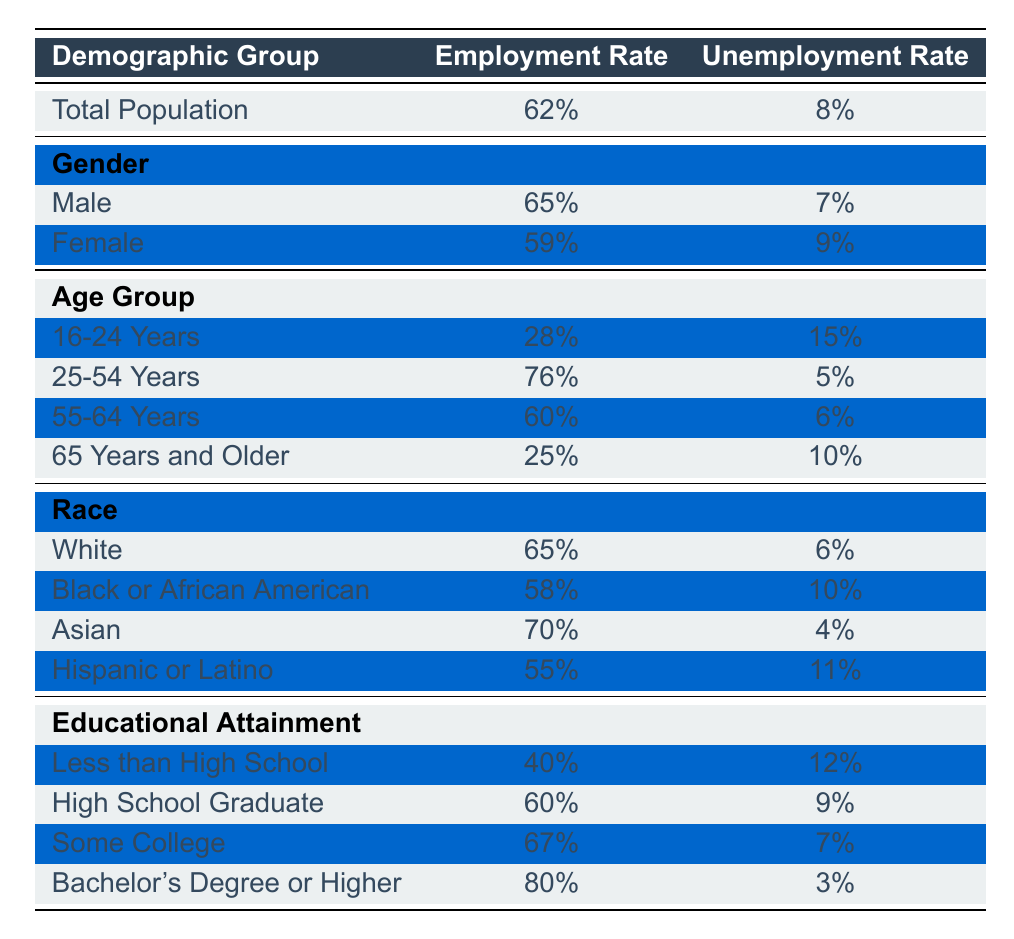What is the employment rate for the total population? The table lists the total employment rate for the population under "Total Population." That rate is explicitly stated as 62%.
Answer: 62% What is the unemployment rate for females? The unemployment rate for females is provided under the "Gender" section in the table, which states that the unemployment rate is 9%.
Answer: 9% Which age group has the highest employment rate? By reviewing the "Age Group" section, we see that the employment rates are: 16-24 Years (28%), 25-54 Years (76%), 55-64 Years (60%), and 65 Years and Older (25%). The highest is 76% for the 25-54 Years group.
Answer: 25-54 Years Is the unemployment rate for Black or African American individuals higher than that of White individuals? The unemployment rate for Black or African American individuals is 10% while for White individuals it is 6%. Since 10% is greater than 6%, the statement is true.
Answer: Yes What is the difference in employment rates between males and females? The employment rate for males is 65%, and for females, it is 59%. The difference can be calculated as 65% - 59% = 6%.
Answer: 6% What is the average employment rate for individuals with a Bachelor's Degree or Higher compared to those with less than a High School diploma? The employment rate for a Bachelor's Degree or Higher is 80%, and for Less than High School, it is 40%. To find the average, add both and divide by 2: (80% + 40%) / 2 = 60%.
Answer: 60% Does the employment rate for the Asian demographic group exceed 70%? The employment rate for the Asian demographic group is listed as 70%. Since it is not greater than 70%, the statement is false.
Answer: No Which demographic has the lowest unemployment rate? Looking through all sections, the lowest unemployment rate is found in the "Bachelor's Degree or Higher" category at 3%. This is lower than other groups specified in the table.
Answer: Bachelor's Degree or Higher What is the average employment rate for the age groups 55-64 Years and 65 Years and Older? The employment rates for these age groups are 60% for 55-64 Years and 25% for 65 Years and Older. The average is calculated as (60% + 25%) / 2 = 42.5%.
Answer: 42.5% 